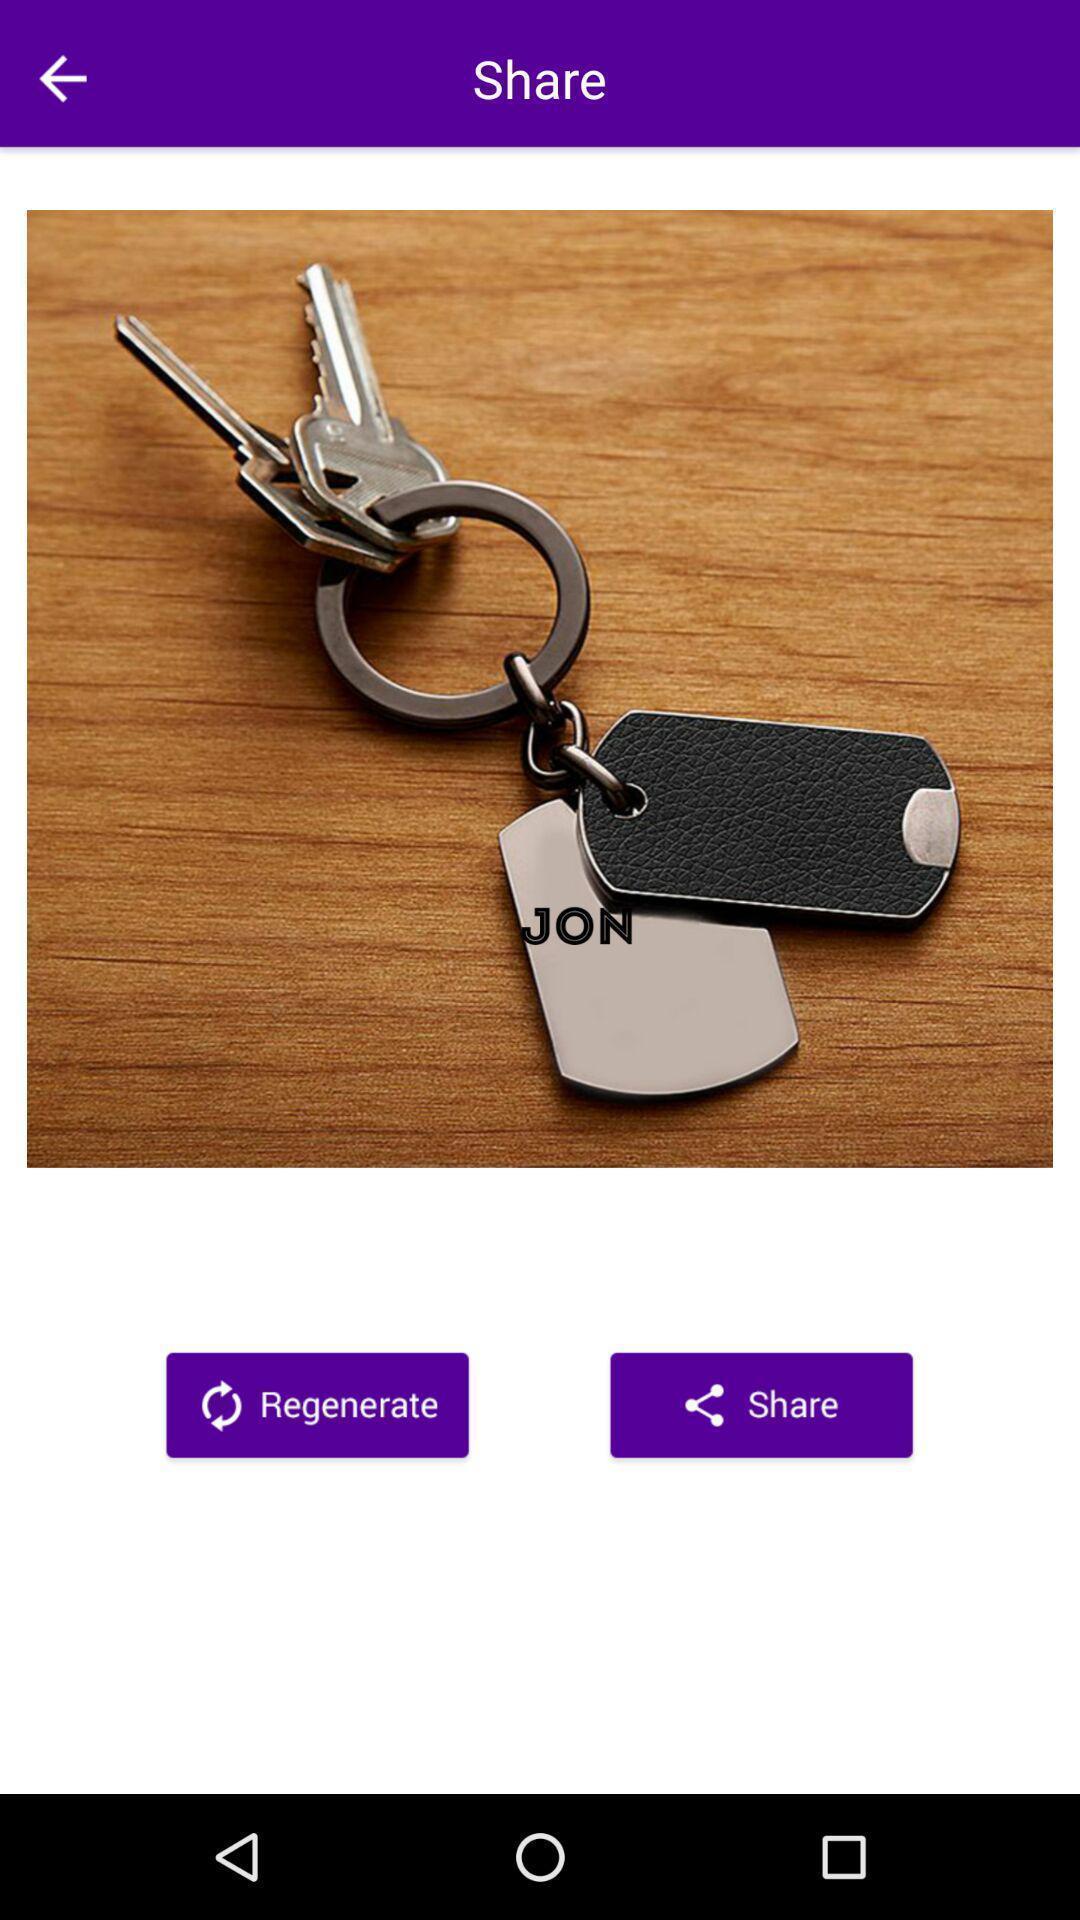Give me a narrative description of this picture. Page shows the keys image to regenerate or share. 